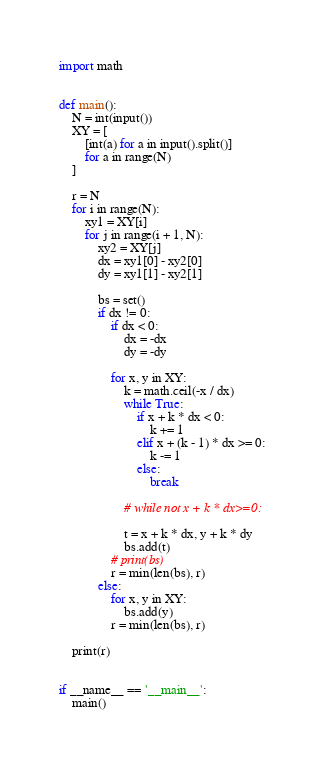<code> <loc_0><loc_0><loc_500><loc_500><_Python_>import math


def main():
    N = int(input())
    XY = [
        [int(a) for a in input().split()]
        for a in range(N)
    ]

    r = N
    for i in range(N):
        xy1 = XY[i]
        for j in range(i + 1, N):
            xy2 = XY[j]
            dx = xy1[0] - xy2[0]
            dy = xy1[1] - xy2[1]

            bs = set()
            if dx != 0:
                if dx < 0:
                    dx = -dx
                    dy = -dy

                for x, y in XY:
                    k = math.ceil(-x / dx)
                    while True:
                        if x + k * dx < 0:
                            k += 1
                        elif x + (k - 1) * dx >= 0:
                            k -= 1
                        else:
                            break

                    # while not x + k * dx>=0:

                    t = x + k * dx, y + k * dy
                    bs.add(t)
                # print(bs)
                r = min(len(bs), r)
            else:
                for x, y in XY:
                    bs.add(y)
                r = min(len(bs), r)

    print(r)


if __name__ == '__main__':
    main()
</code> 